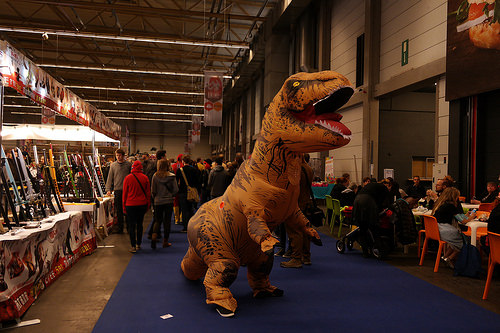<image>
Is there a dinosaur under the lights? Yes. The dinosaur is positioned underneath the lights, with the lights above it in the vertical space. 